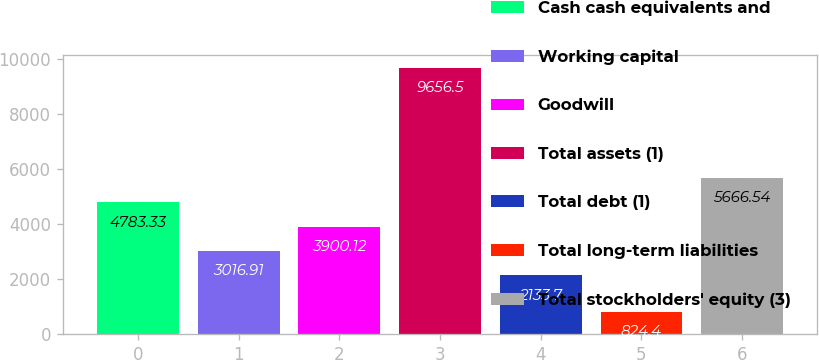Convert chart to OTSL. <chart><loc_0><loc_0><loc_500><loc_500><bar_chart><fcel>Cash cash equivalents and<fcel>Working capital<fcel>Goodwill<fcel>Total assets (1)<fcel>Total debt (1)<fcel>Total long-term liabilities<fcel>Total stockholders' equity (3)<nl><fcel>4783.33<fcel>3016.91<fcel>3900.12<fcel>9656.5<fcel>2133.7<fcel>824.4<fcel>5666.54<nl></chart> 